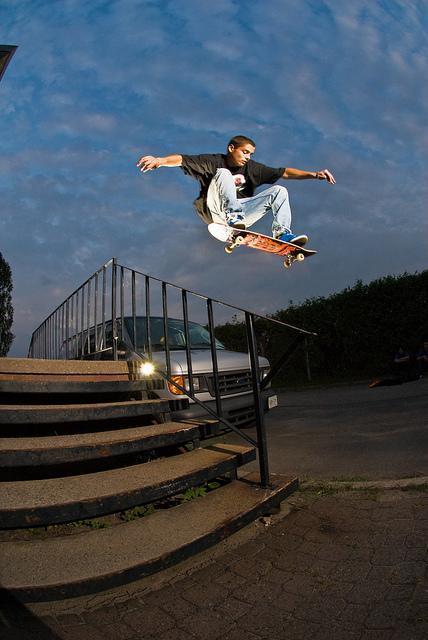How many stairs are there?
Give a very brief answer. 5. How many steps is the guy jumping over?
Give a very brief answer. 5. How many kids in the picture?
Give a very brief answer. 1. How many zebras are drinking water?
Give a very brief answer. 0. 